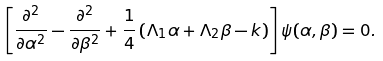Convert formula to latex. <formula><loc_0><loc_0><loc_500><loc_500>\left [ \frac { \partial ^ { 2 } } { \partial \alpha ^ { 2 } } - \frac { \partial ^ { 2 } } { \partial \beta ^ { 2 } } + \frac { 1 } { 4 } \left ( \Lambda _ { 1 } \alpha + \Lambda _ { 2 } \beta - k \right ) \right ] \psi ( \alpha , \beta ) = 0 .</formula> 